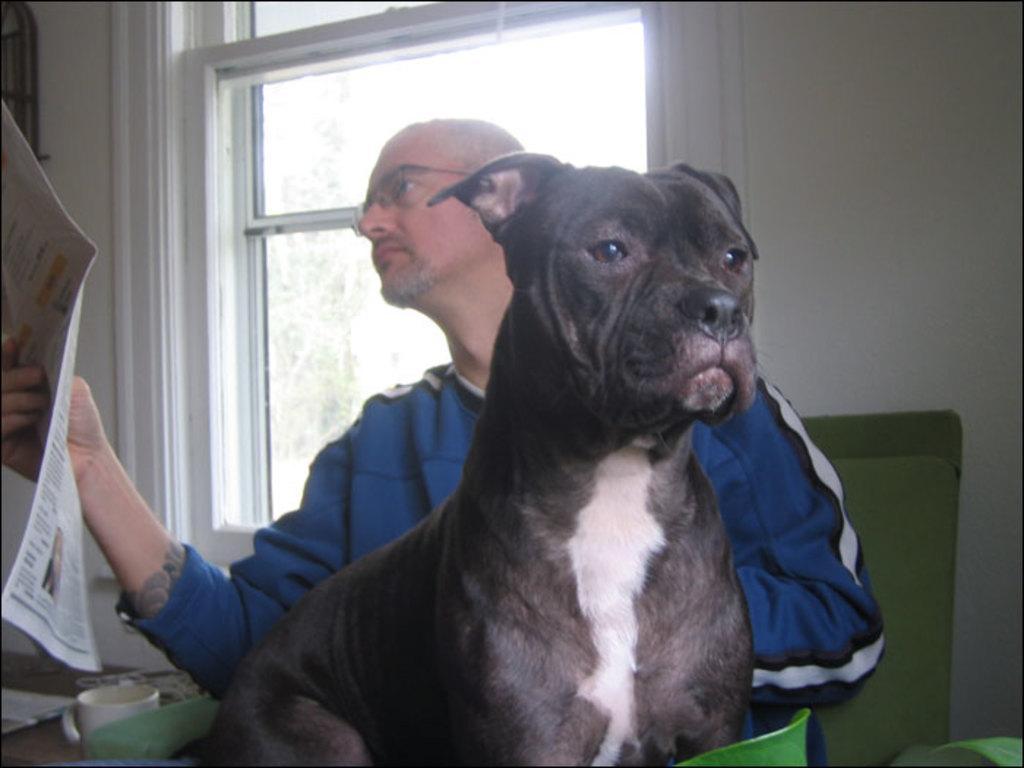Could you give a brief overview of what you see in this image? A man on the chair holding a newspaper in his right hand and there is a window on his right hand side and a dog on his left hand side. 